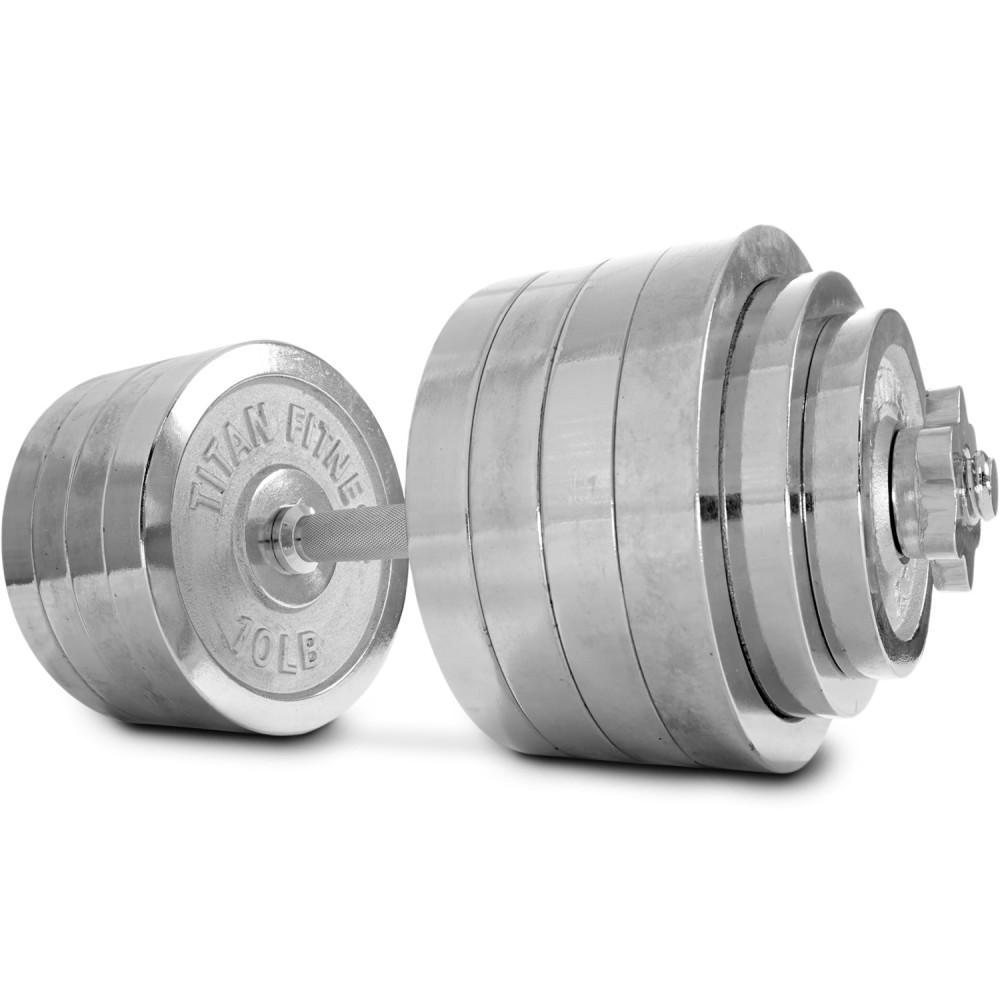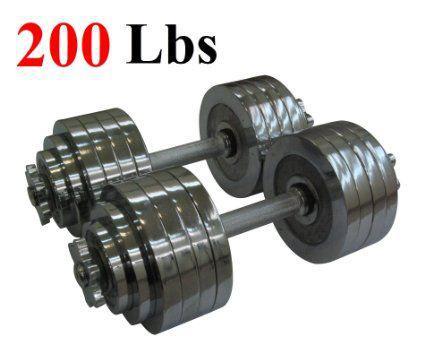The first image is the image on the left, the second image is the image on the right. Analyze the images presented: Is the assertion "There is a single dumbbell in the left image." valid? Answer yes or no. Yes. The first image is the image on the left, the second image is the image on the right. Given the left and right images, does the statement "There is a total of three dumbells with six sets of circle weights on it." hold true? Answer yes or no. Yes. 